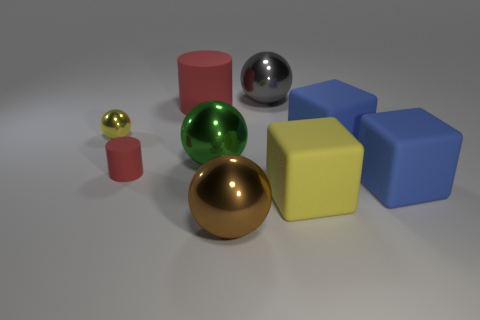What color is the matte cylinder that is the same size as the yellow matte block? The matte cylinder that matches the size of the yellow block is red. This cylinder, like the block, has a matte finish which diffuses the light, giving it a soft, non-reflective surface compared to the shiny spheres nearby. 